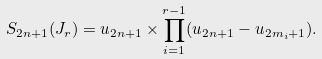Convert formula to latex. <formula><loc_0><loc_0><loc_500><loc_500>S _ { 2 n + 1 } ( J _ { r } ) = u _ { 2 n + 1 } \times \prod _ { i = 1 } ^ { r - 1 } ( u _ { 2 n + 1 } - u _ { 2 m _ { i } + 1 } ) .</formula> 